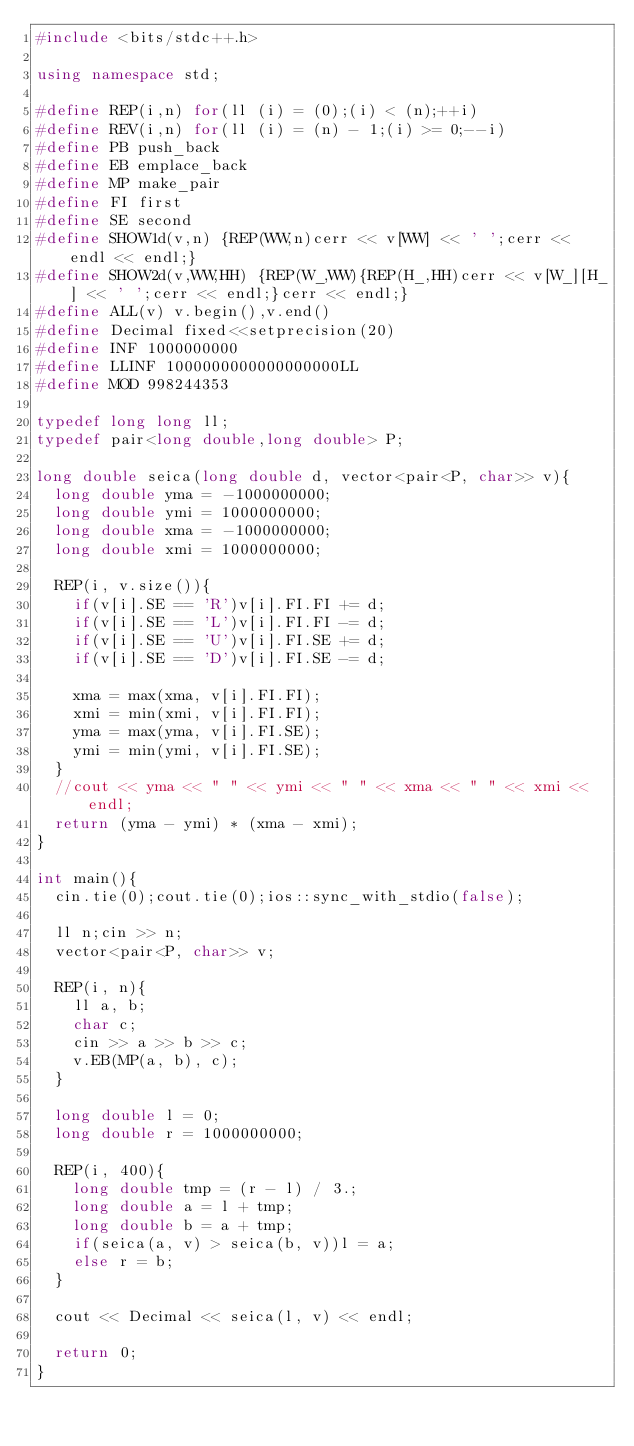Convert code to text. <code><loc_0><loc_0><loc_500><loc_500><_C++_>#include <bits/stdc++.h>

using namespace std;

#define REP(i,n) for(ll (i) = (0);(i) < (n);++i)
#define REV(i,n) for(ll (i) = (n) - 1;(i) >= 0;--i)
#define PB push_back
#define EB emplace_back
#define MP make_pair
#define FI first
#define SE second
#define SHOW1d(v,n) {REP(WW,n)cerr << v[WW] << ' ';cerr << endl << endl;}
#define SHOW2d(v,WW,HH) {REP(W_,WW){REP(H_,HH)cerr << v[W_][H_] << ' ';cerr << endl;}cerr << endl;}
#define ALL(v) v.begin(),v.end()
#define Decimal fixed<<setprecision(20)
#define INF 1000000000
#define LLINF 1000000000000000000LL
#define MOD 998244353

typedef long long ll;
typedef pair<long double,long double> P;

long double seica(long double d, vector<pair<P, char>> v){
	long double yma = -1000000000;
	long double ymi = 1000000000;
	long double xma = -1000000000;
	long double xmi = 1000000000;

	REP(i, v.size()){
		if(v[i].SE == 'R')v[i].FI.FI += d;
		if(v[i].SE == 'L')v[i].FI.FI -= d;
		if(v[i].SE == 'U')v[i].FI.SE += d;
		if(v[i].SE == 'D')v[i].FI.SE -= d;

		xma = max(xma, v[i].FI.FI);
		xmi = min(xmi, v[i].FI.FI);
		yma = max(yma, v[i].FI.SE);
		ymi = min(ymi, v[i].FI.SE);
	}
	//cout << yma << " " << ymi << " " << xma << " " << xmi << endl;
	return (yma - ymi) * (xma - xmi);
}

int main(){
	cin.tie(0);cout.tie(0);ios::sync_with_stdio(false);

	ll n;cin >> n;
	vector<pair<P, char>> v;

	REP(i, n){
		ll a, b;
		char c;
		cin >> a >> b >> c;
		v.EB(MP(a, b), c);
	}

	long double l = 0;
	long double r = 1000000000;

	REP(i, 400){
		long double tmp = (r - l) / 3.;
		long double a = l + tmp;
		long double b = a + tmp;
		if(seica(a, v) > seica(b, v))l = a;
		else r = b;
	}

	cout << Decimal << seica(l, v) << endl;

	return 0;
}
</code> 